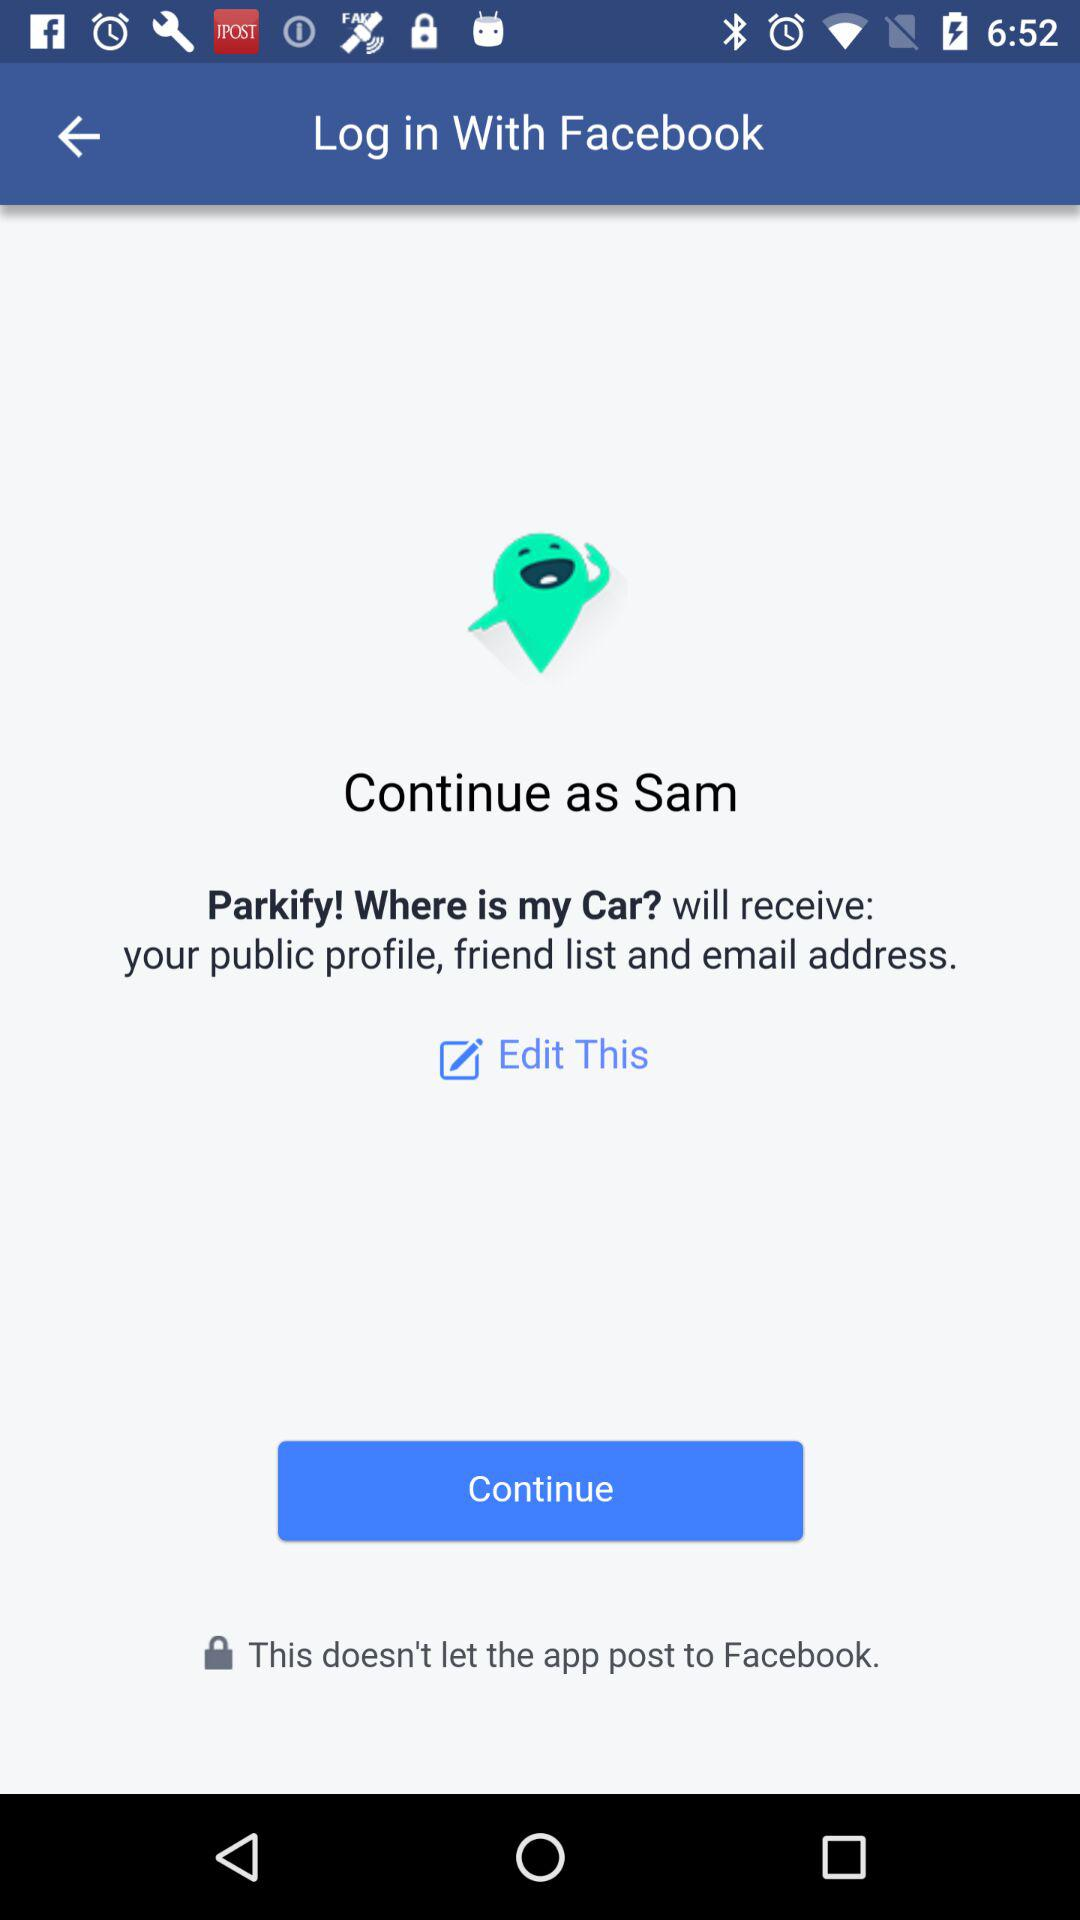What application is asking for permission? The application is "Parkify! Where is my Car?". 